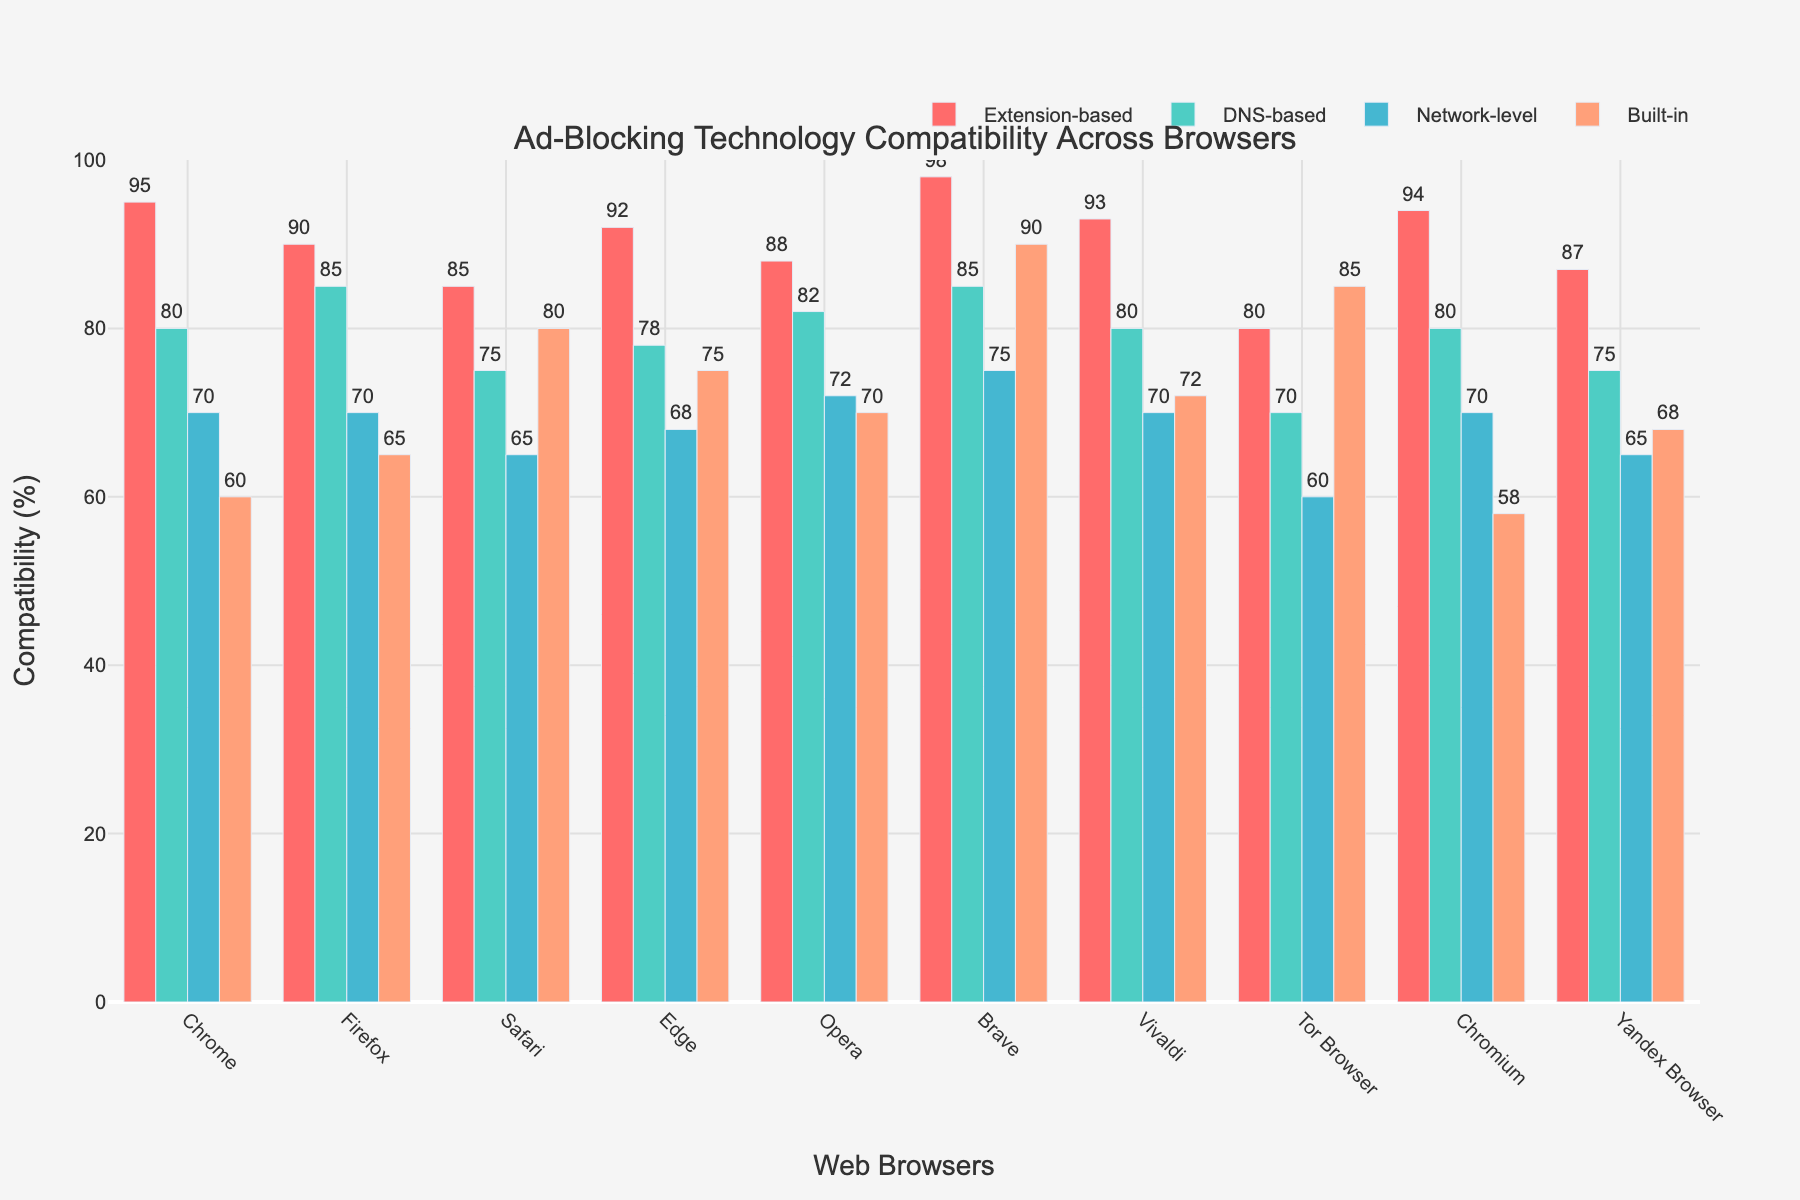Which browser has the highest compatibility for extension-based ad-blocking technologies? By inspecting the height of the bars for the "Extension-based" technology, we can see which one reaches the highest value. Brave has the bar with the highest value at 98%.
Answer: Brave What is the average compatibility of DNS-based ad-blocking across all browsers? Sum up the values for DNS-based compatibility for all browsers (80 + 85 + 75 + 78 + 82 + 85 + 80 + 70 + 80 + 75 = 790) and divide by the number of browsers (790 / 10).
Answer: 79% Which browser has the lowest network-level ad-blocking compatibility? By comparing the heights of the bars for the "Network-level" technology, we see that Tor Browser has the lowest bar at 60%.
Answer: Tor Browser What is the difference in built-in ad-blocking compatibility between Safari and Chrome? The value for Safari is 80% and for Chrome is 60%. Subtract the smaller value from the larger value (80% - 60%).
Answer: 20% Which ad-blocking technology has the most uniform compatibility across all browsers? Assess each technology by looking at the heights of their respective bars. "Extension-based" has the most uniform height distribution across browsers, varying slightly around the highest end.
Answer: Extension-based How does Firefox compare to Vivaldi in terms of DNS-based compatibility? The height of the bar for DNS-based technology shows 85% for Firefox and 80% for Vivaldi. Comparing these values, Firefox is higher.
Answer: Firefox has higher DNS-based compatibility Which ad-blocking technology does Brave perform best in? Inspect the bars for Brave across all ad-blocking technologies. The bar that reaches the highest value is "Built-in" at 90%.
Answer: Built-in What is the total compatibility percentage for Chrome across all ad-blocking technologies? Add up the values for Chrome: 95% + 80% + 70% + 60% = 305%.
Answer: 305% What is the median value of network-level ad-blocking compatibility across the browsers? Sort the network-level values: 60, 65, 68, 70, 70, 70, 70, 72, 75, and 75. The median is the average of the 5th and 6th values in the sorted list (70 and 70).
Answer: 70% What is the combined superiority in extension-based compatibility for the two most performing browsers compared to Vivaldi? The two highest 'Extension-based' values are Brave (98%) and Chrome (95%). The combined value is (98% + 95% = 193%). Subtract Vivaldi's value (93%) from this combined value (193% - 93%).
Answer: 100% 